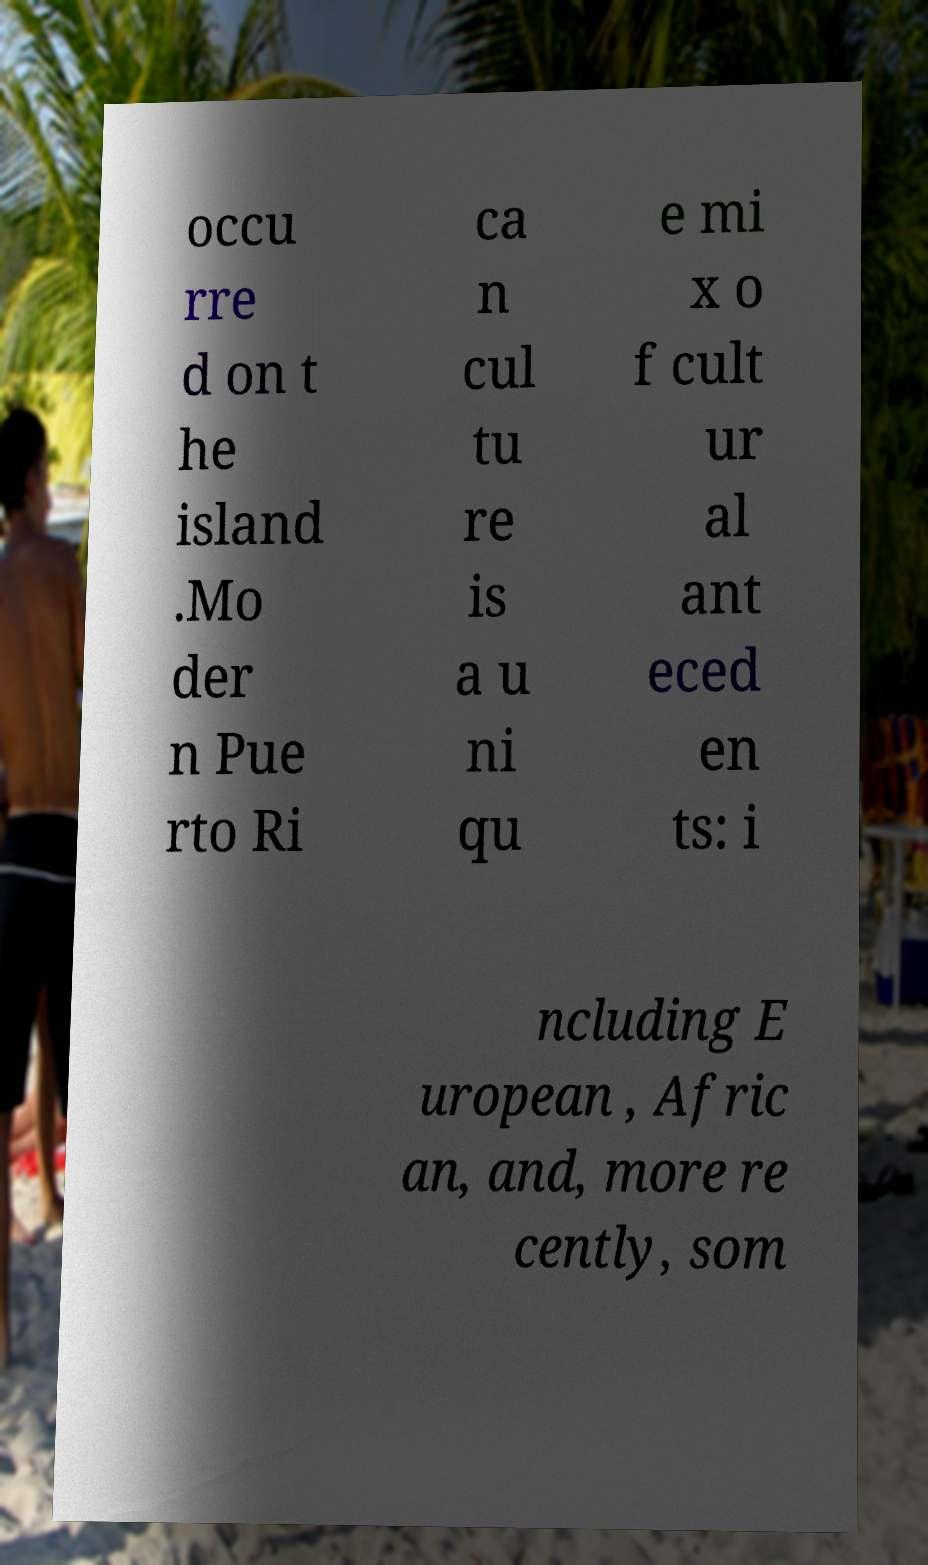Could you extract and type out the text from this image? occu rre d on t he island .Mo der n Pue rto Ri ca n cul tu re is a u ni qu e mi x o f cult ur al ant eced en ts: i ncluding E uropean , Afric an, and, more re cently, som 